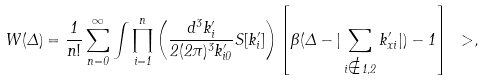Convert formula to latex. <formula><loc_0><loc_0><loc_500><loc_500>W ( \Delta ) = \frac { 1 } { n ! } \sum _ { n = 0 } ^ { \infty } \int \prod _ { i = 1 } ^ { n } \left ( \frac { d ^ { 3 } k ^ { \prime } _ { i } } { 2 ( 2 \pi ) ^ { 3 } k ^ { \prime } _ { i 0 } } S [ k ^ { \prime } _ { i } ] \right ) \left [ \Theta ( \Delta - | \sum _ { i \notin 1 , 2 } k ^ { \prime } _ { x i } | ) - 1 \right ] \ > ,</formula> 